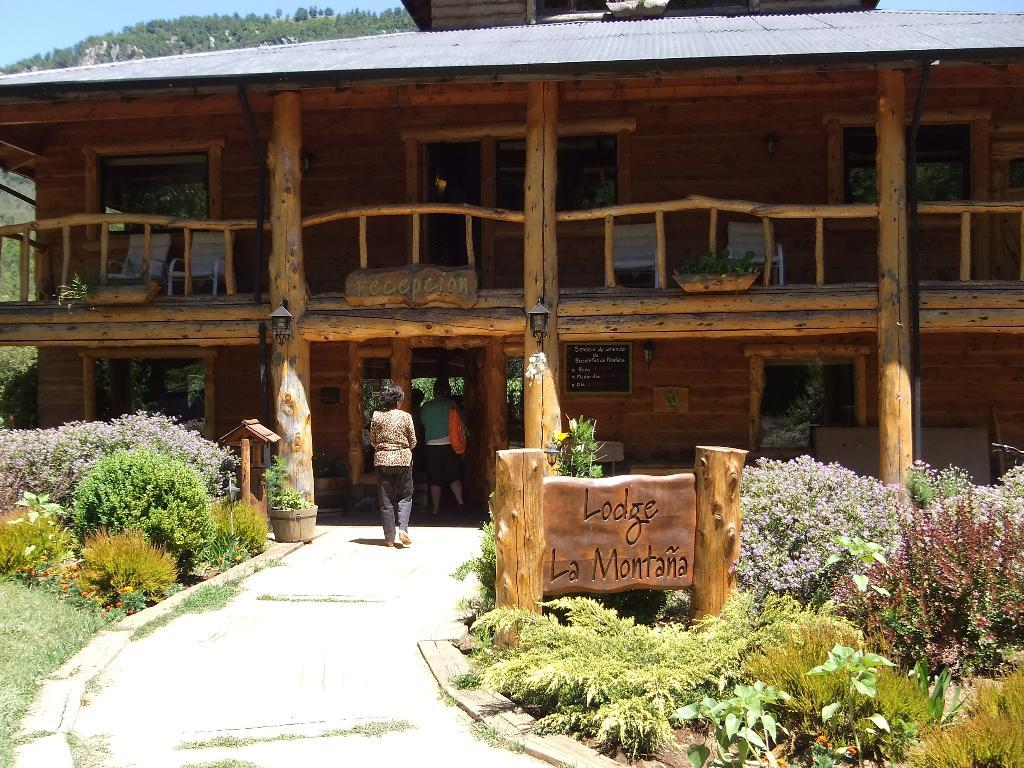<image>
Describe the image concisely. people walking into a building with a wooden sign in front of it that says 'lodge la montana' 